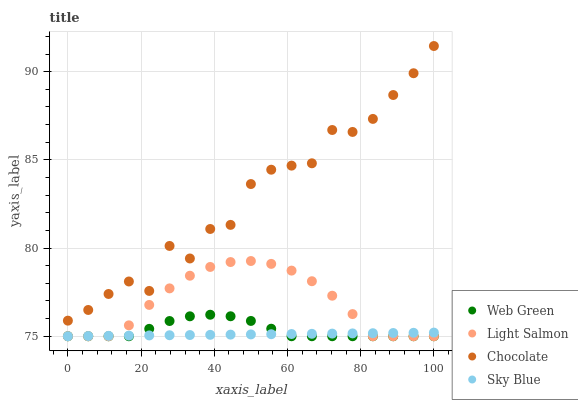Does Sky Blue have the minimum area under the curve?
Answer yes or no. Yes. Does Chocolate have the maximum area under the curve?
Answer yes or no. Yes. Does Light Salmon have the minimum area under the curve?
Answer yes or no. No. Does Light Salmon have the maximum area under the curve?
Answer yes or no. No. Is Sky Blue the smoothest?
Answer yes or no. Yes. Is Chocolate the roughest?
Answer yes or no. Yes. Is Light Salmon the smoothest?
Answer yes or no. No. Is Light Salmon the roughest?
Answer yes or no. No. Does Sky Blue have the lowest value?
Answer yes or no. Yes. Does Chocolate have the lowest value?
Answer yes or no. No. Does Chocolate have the highest value?
Answer yes or no. Yes. Does Light Salmon have the highest value?
Answer yes or no. No. Is Web Green less than Chocolate?
Answer yes or no. Yes. Is Chocolate greater than Web Green?
Answer yes or no. Yes. Does Web Green intersect Sky Blue?
Answer yes or no. Yes. Is Web Green less than Sky Blue?
Answer yes or no. No. Is Web Green greater than Sky Blue?
Answer yes or no. No. Does Web Green intersect Chocolate?
Answer yes or no. No. 